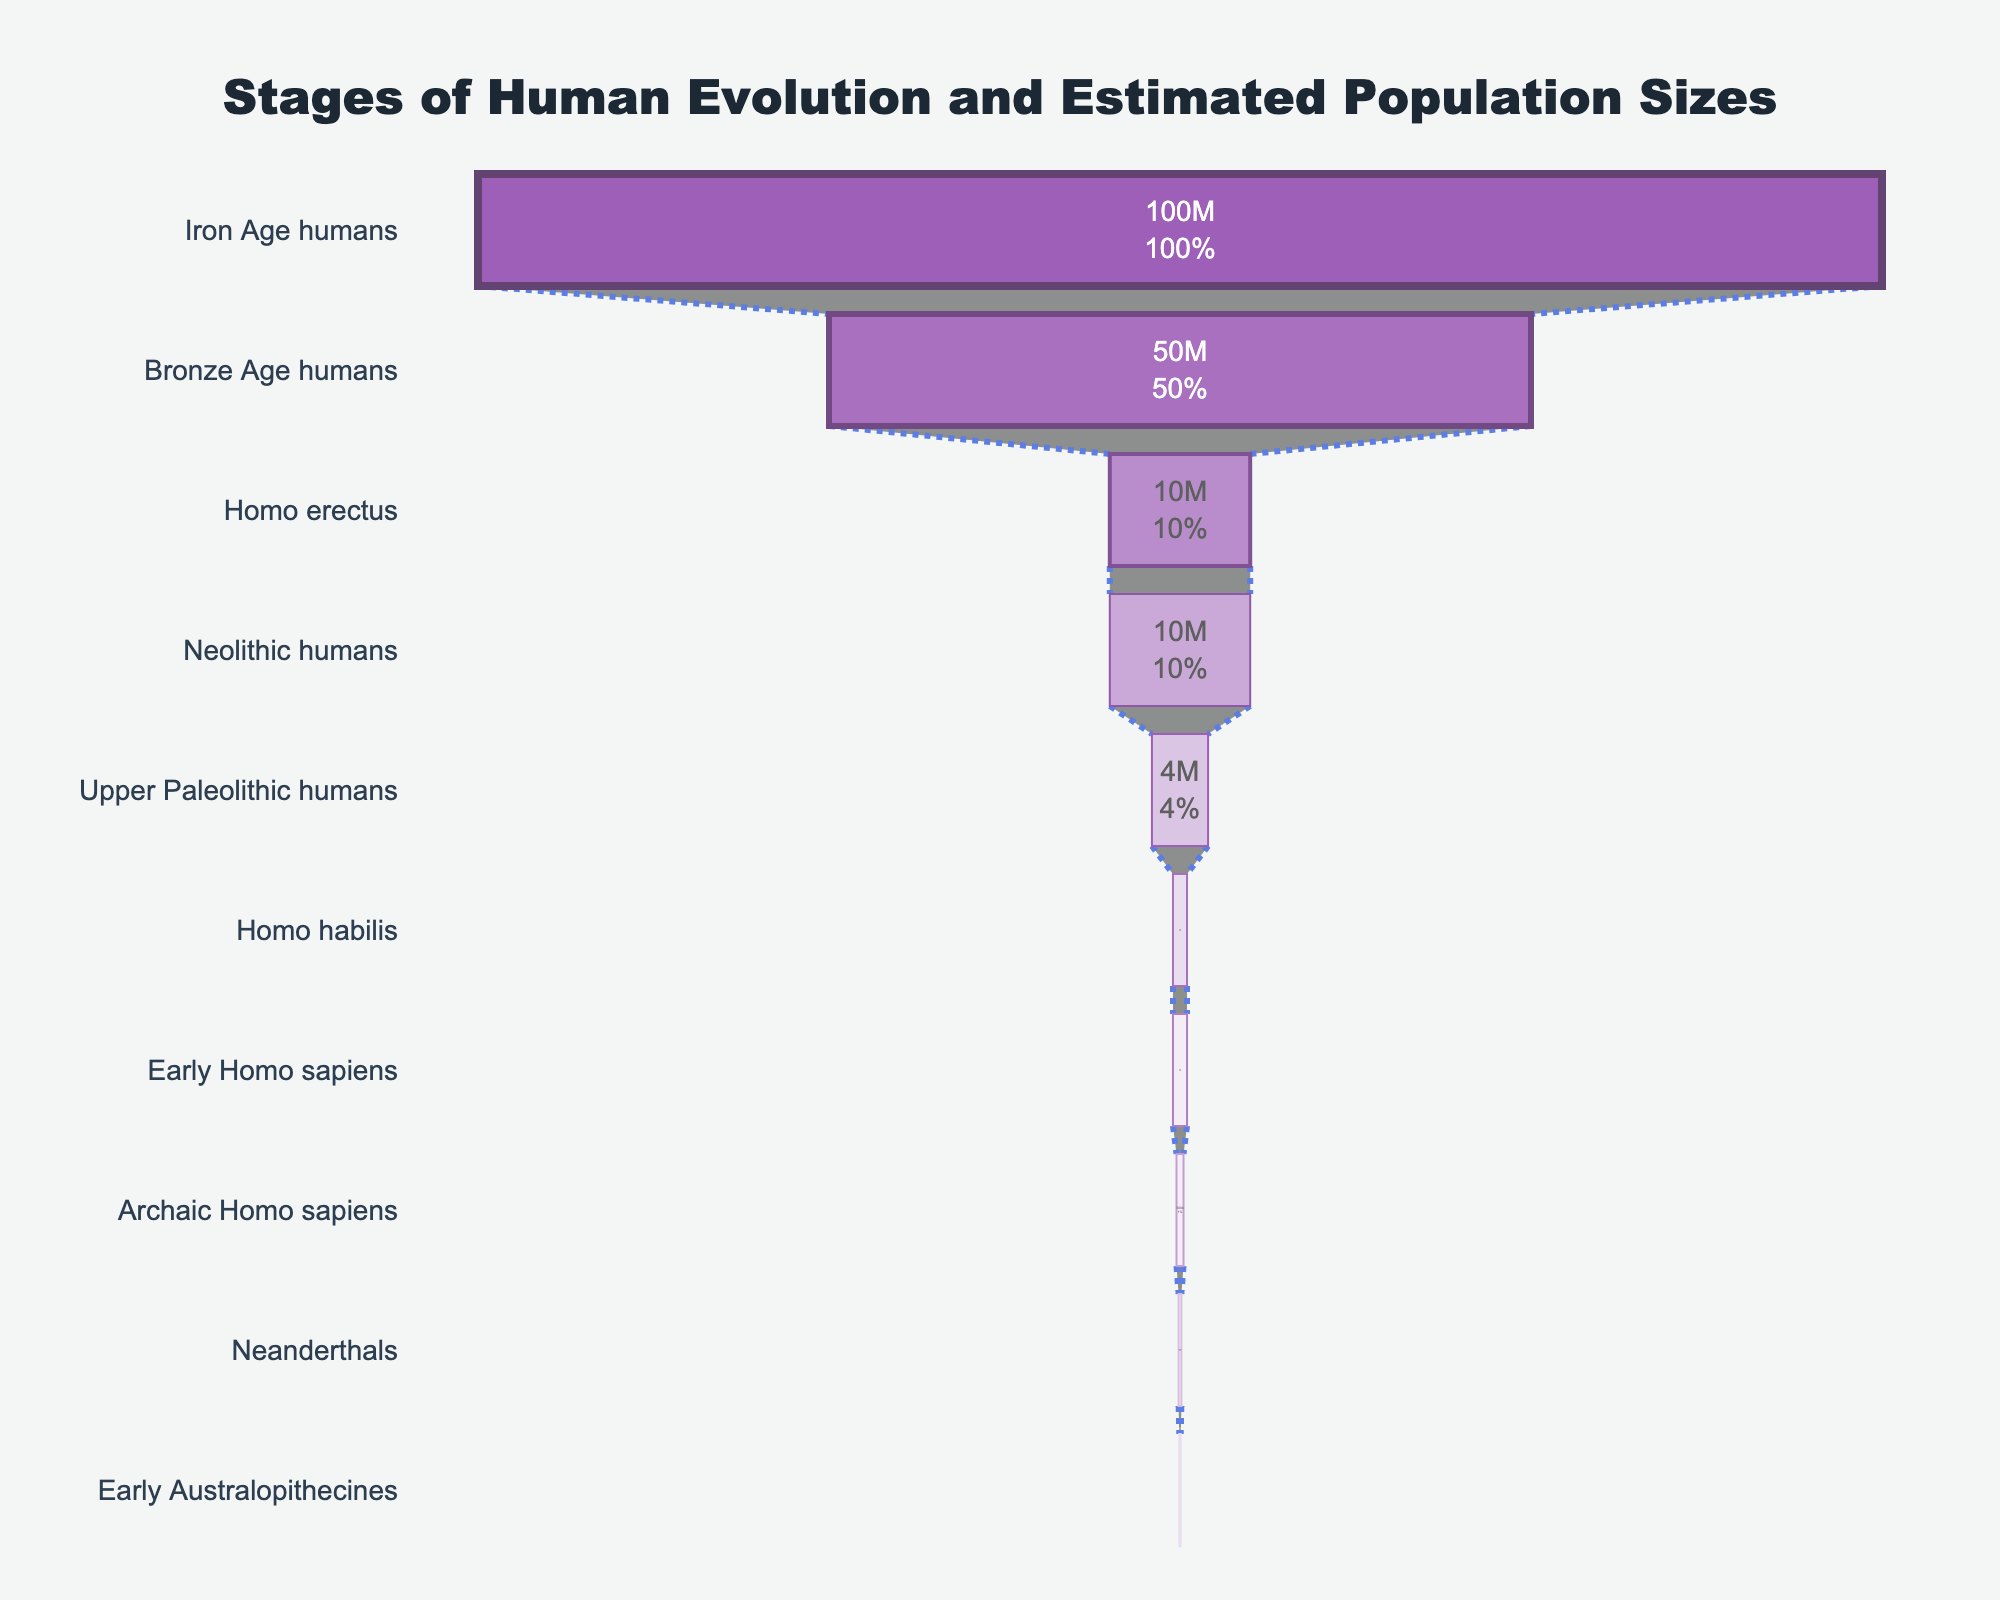What's the title of the funnel chart? The title is located at the top of the chart and provides the main topic of the visualization.
Answer: Stages of Human Evolution and Estimated Population Sizes How many stages of human evolution are presented in the funnel chart? Count the number of stages listed on the y-axis.
Answer: 10 Which stage has the highest estimated population? Identify the stage with the longest bar in the funnel chart.
Answer: Iron Age humans What is the estimated population of Neanderthals? Find the label associated with Neanderthals in the chart, and read the value displayed inside or alongside the bar.
Answer: 200,000 Which stages have the same estimated population of 100,000? Look for labels with an estimated population of 100,000, and identify the stages associated with these labels.
Answer: Early Australopithecines What's the total of the estimated populations of Homo habilis, Early Homo sapiens, and Upper Paleolithic humans? Sum the estimated populations of the three stages: 1,000,000 (Homo habilis) + 1,000,000 (Early Homo sapiens) + 4,000,000 (Upper Paleolithic humans).
Answer: 6,000,000 Which stage has a higher population, Archaic Homo sapiens or Neanderthals? Compare the estimated populations of Archaic Homo sapiens (500,000) and Neanderthals (200,000).
Answer: Archaic Homo sapiens How does the population of Early Homo sapiens compare to that of Homo erectus? Compare the estimated populations of Early Homo sapiens (1,000,000) and Homo erectus (10,000,000).
Answer: Smaller What percentage of the initial population does the Bronze Age human stage represent? Find the percentage value displayed inside the bar for Bronze Age humans.
Answer: 50% Which two stages have the greatest difference in population estimates? Identify the stages with the maximum and minimum population estimates: Iron Age humans (100,000,000) and Early Australopithecines (100,000). The difference is 100,000,000 - 100,000.
Answer: Iron Age humans and Early Australopithecines 